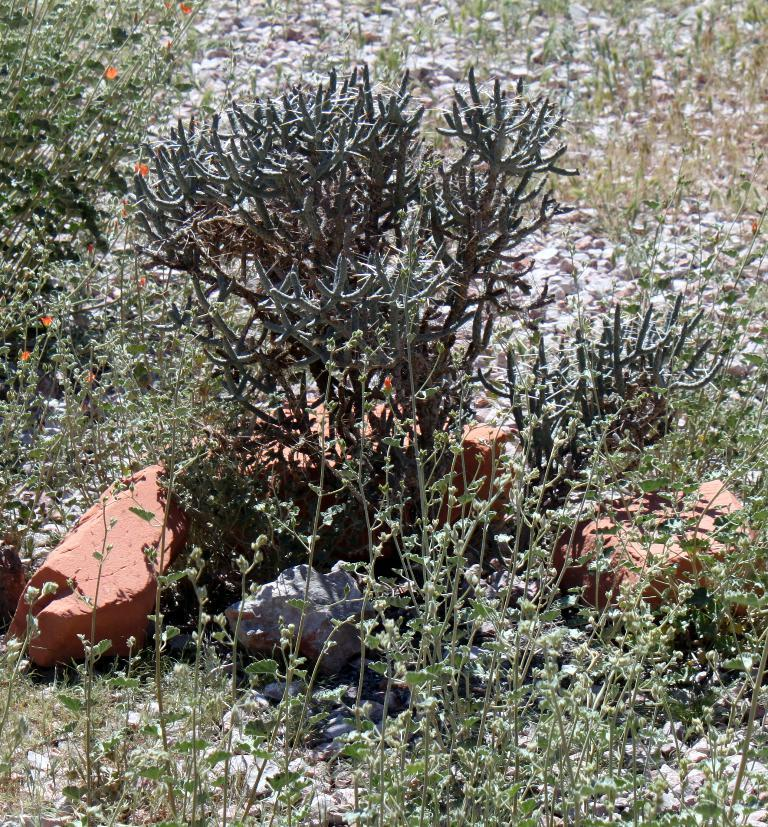What objects are located at the bottom left side of the image? There are two stones at the bottom left side of the image. What can be seen in the background of the image? There are plants in the background of the image. What type of curtain can be seen hanging in the image? There is no curtain present in the image. How many bushes are visible in the image? The provided facts do not mention bushes, so we cannot determine the number of bushes in the image. 